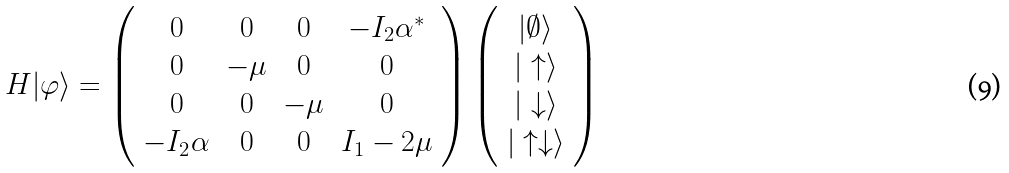<formula> <loc_0><loc_0><loc_500><loc_500>H | \varphi \rangle = \left ( \begin{array} { c c c c } 0 & 0 & 0 & - I _ { 2 } \alpha ^ { * } \\ 0 & - \mu & 0 & 0 \\ 0 & 0 & - \mu & 0 \\ - I _ { 2 } \alpha & 0 & 0 & I _ { 1 } - 2 \mu \end{array} \right ) \left ( \begin{array} { c c c c } | \emptyset \rangle \\ | \uparrow \rangle \\ | \downarrow \rangle \\ | \uparrow \downarrow \rangle \end{array} \right )</formula> 